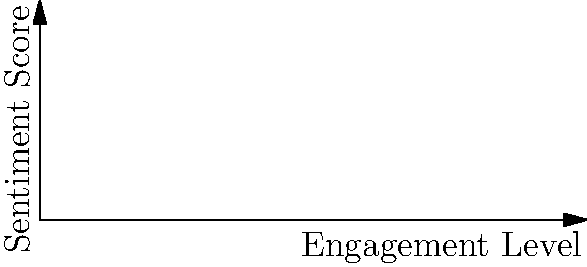Based on the scatter plot showing the clustering of social media users according to their engagement level with vaccination-related content and sentiment score, which clustering algorithm would be most appropriate to identify these distinct groups, and why? To determine the most appropriate clustering algorithm for this data, let's analyze the characteristics of the scatter plot:

1. Number of clusters: The plot shows 3 distinct clusters, each represented by a different color.

2. Shape of clusters: The clusters appear to be roughly spherical or elliptical, with points grouped closely together within each cluster.

3. Separation: The clusters are well-separated from each other, with clear boundaries between them.

4. Size of clusters: The clusters seem to be of similar size, with a comparable number of points in each.

5. Dimensionality: The data is presented in 2D space (engagement level and sentiment score).

Given these observations, the most appropriate clustering algorithm would be K-means clustering. Here's why:

1. K-means is well-suited for datasets with a known number of clusters (in this case, 3).

2. It performs well with spherical or elliptical cluster shapes.

3. K-means is effective when clusters are well-separated and of similar size.

4. The algorithm works efficiently in low-dimensional spaces like this 2D representation.

5. K-means aims to minimize the within-cluster variance, which aligns with the compact nature of the clusters shown.

Other algorithms like hierarchical clustering or DBSCAN could also be considered, but they may not be as optimal given the characteristics of this dataset. Hierarchical clustering might be computationally expensive for large datasets, while DBSCAN is better suited for clusters of varying densities and shapes.
Answer: K-means clustering 